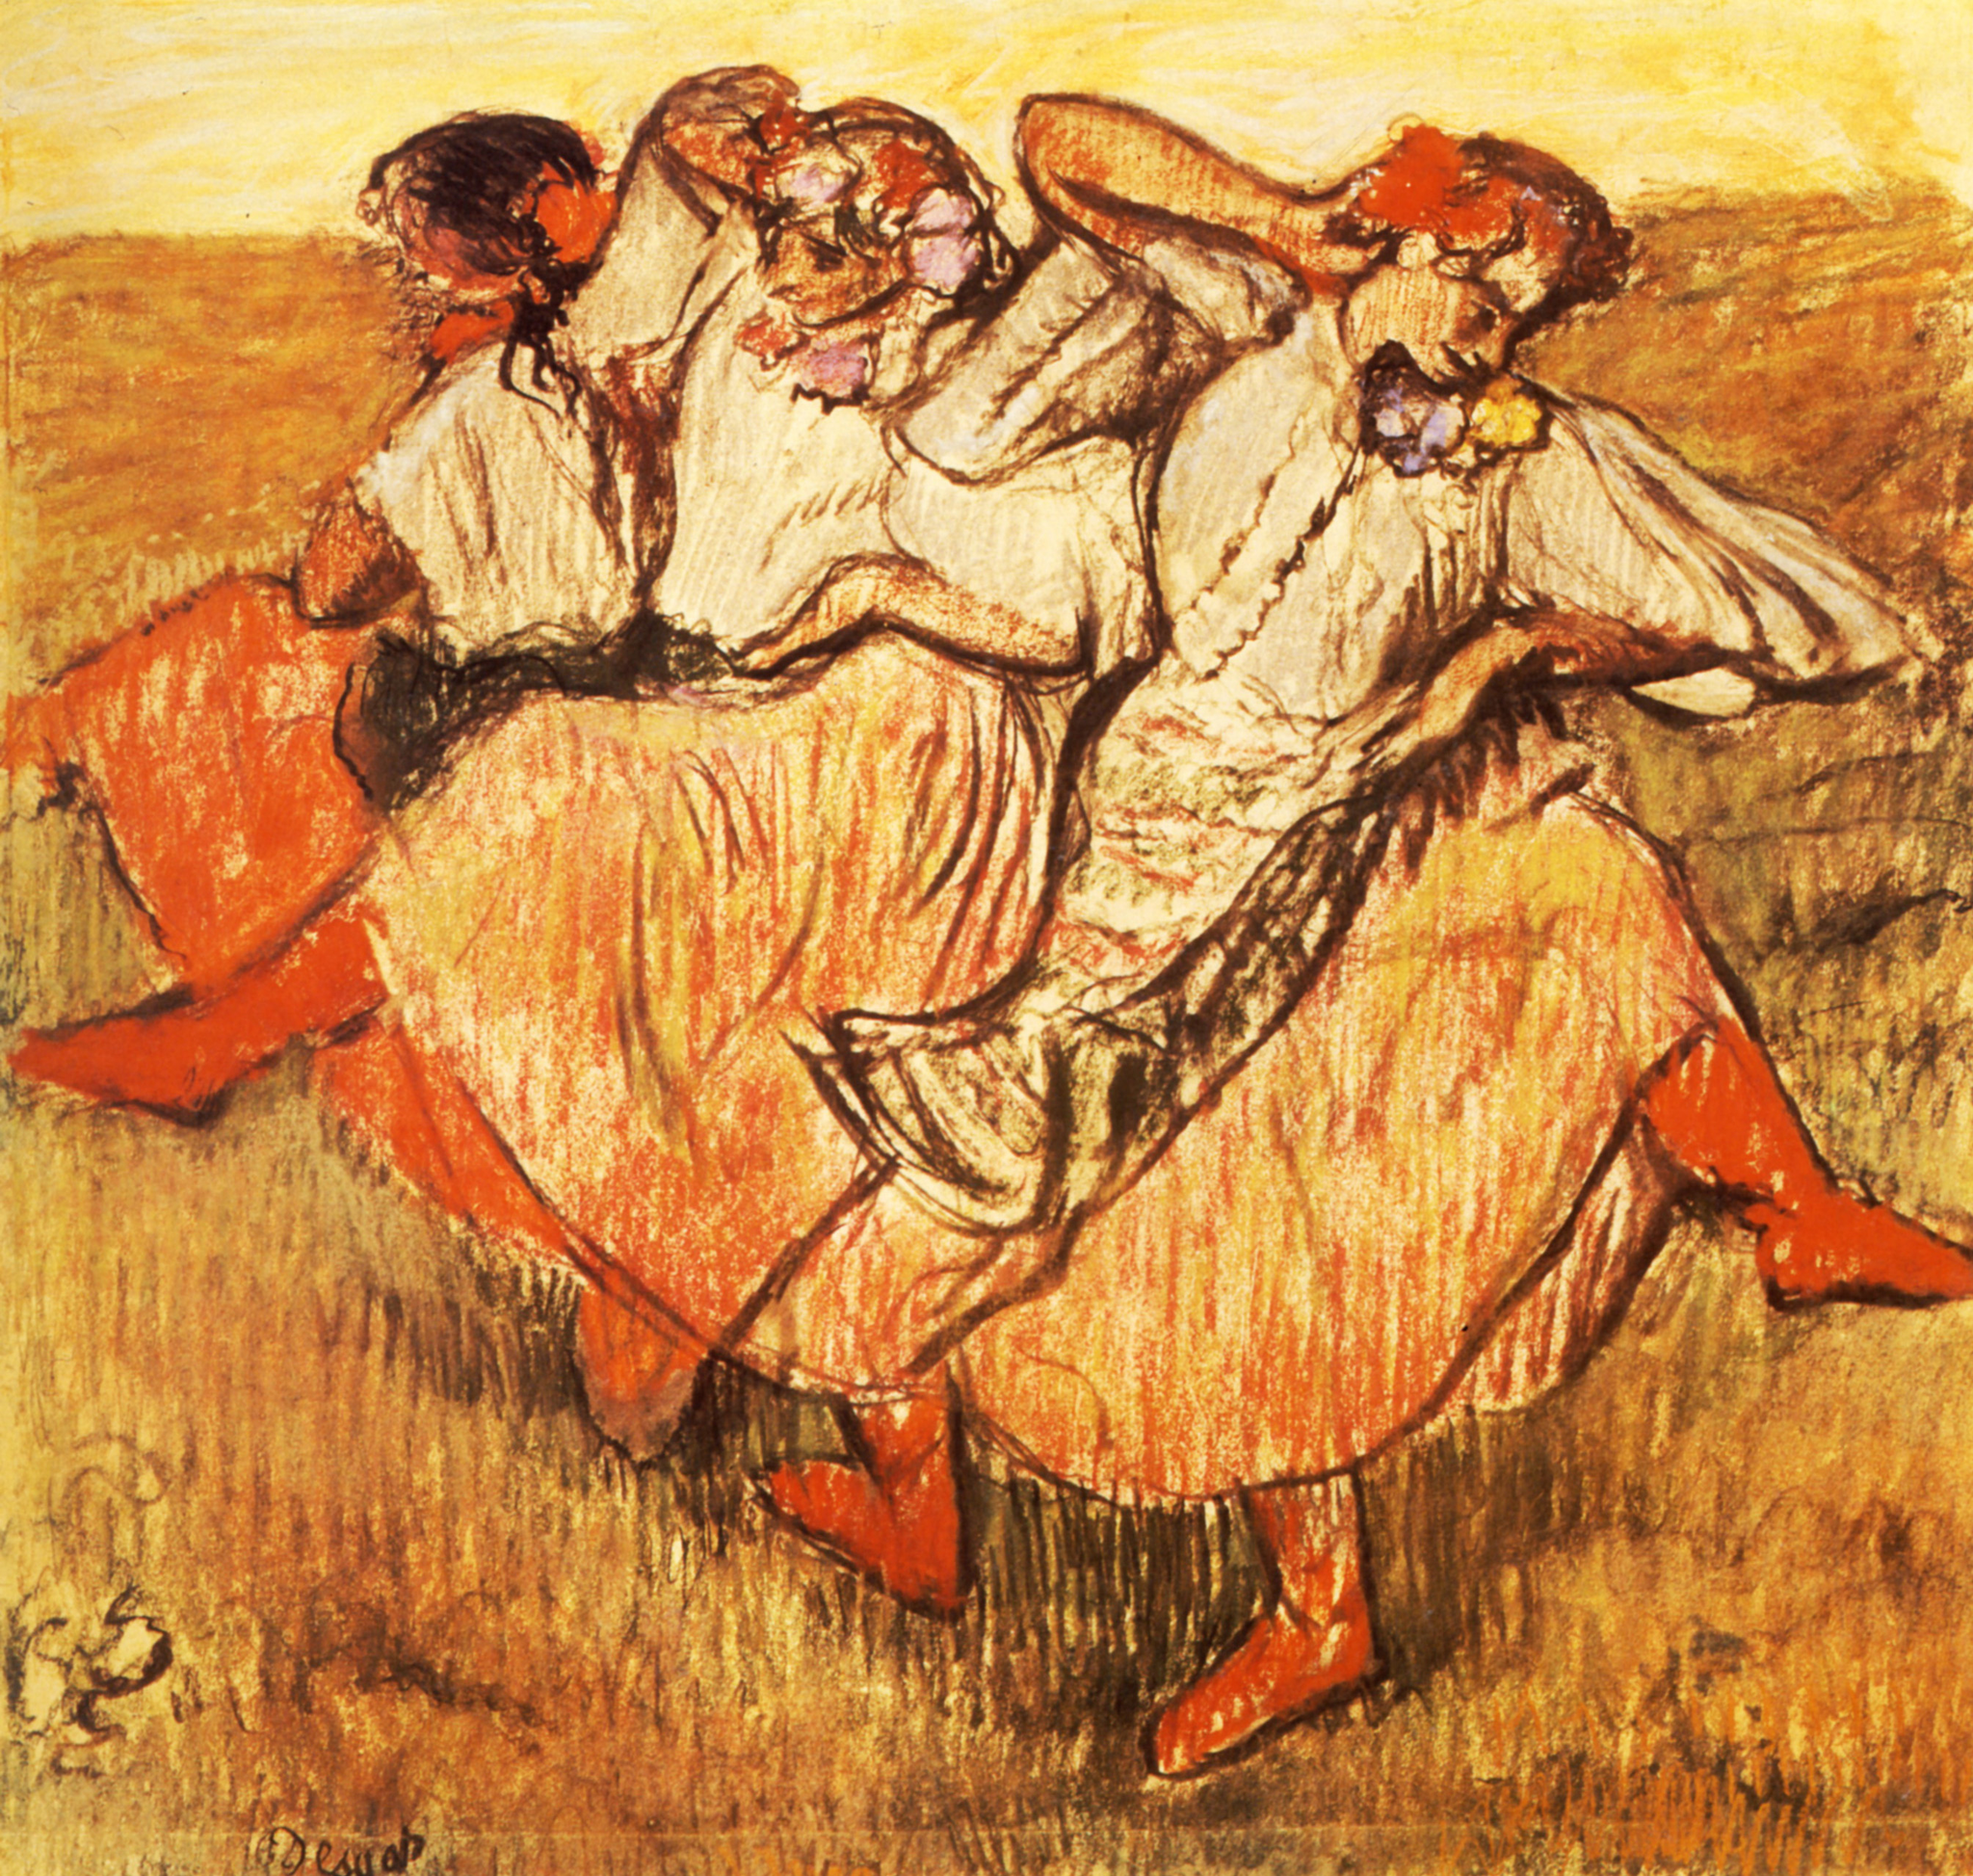How do the women's poses contribute to the overall composition? The women's poses are fluid and dynamic, which adds a sense of rhythm and harmony to the composition. They are captured mid-dance, with their dresses flowing around them, which helps to guide the viewer’s eye through the painting. The arrangement of their arms and the tilt of their bodies, along with the swirling skirts, create a circular motion that serves as the focal point of the artwork. Their positioning captures the spontaneity of the moment and contributes to the depiction of movement that is central to the painting's theme. 